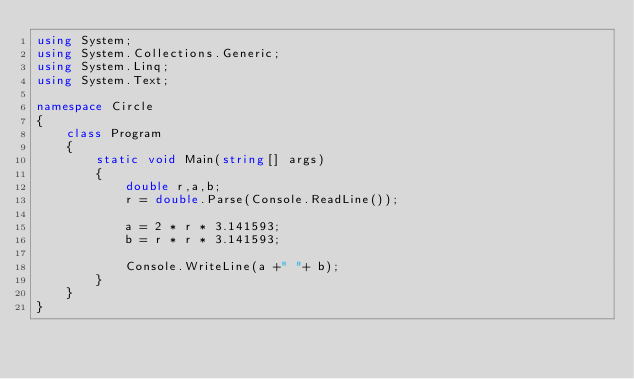<code> <loc_0><loc_0><loc_500><loc_500><_C#_>using System;
using System.Collections.Generic;
using System.Linq;
using System.Text;

namespace Circle
{
    class Program
    {
        static void Main(string[] args)
        {
            double r,a,b;
            r = double.Parse(Console.ReadLine());

            a = 2 * r * 3.141593;
            b = r * r * 3.141593;

            Console.WriteLine(a +" "+ b);
        }
    }
}</code> 